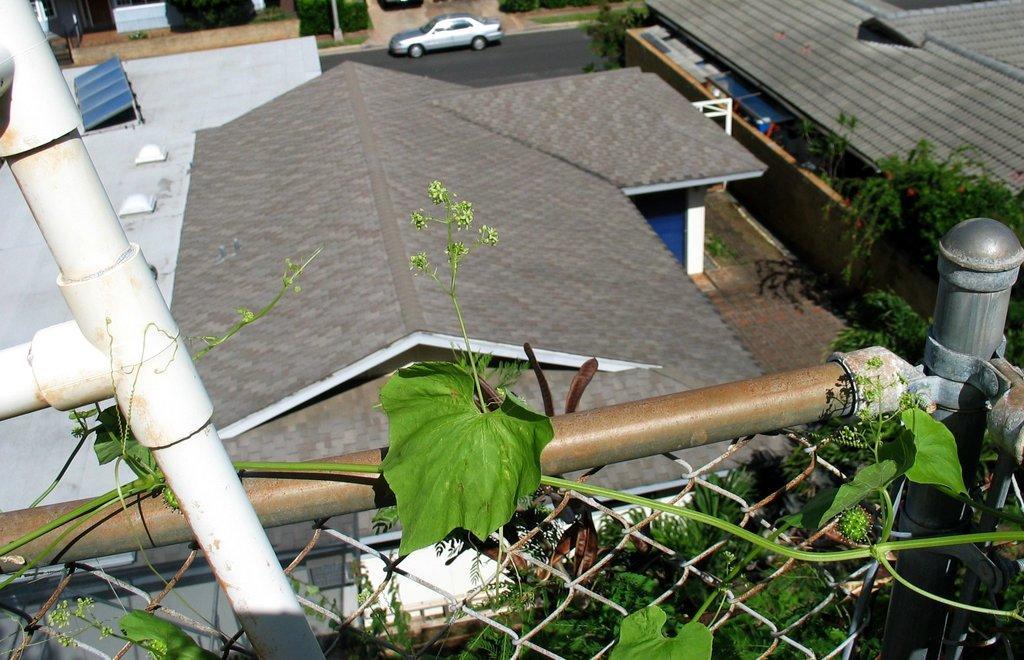Please provide a concise description of this image. In this image we can see a plant leaf on the fence. In the background ,we can see group of buildings ,a car parked on the ground ,poles and group of trees. 